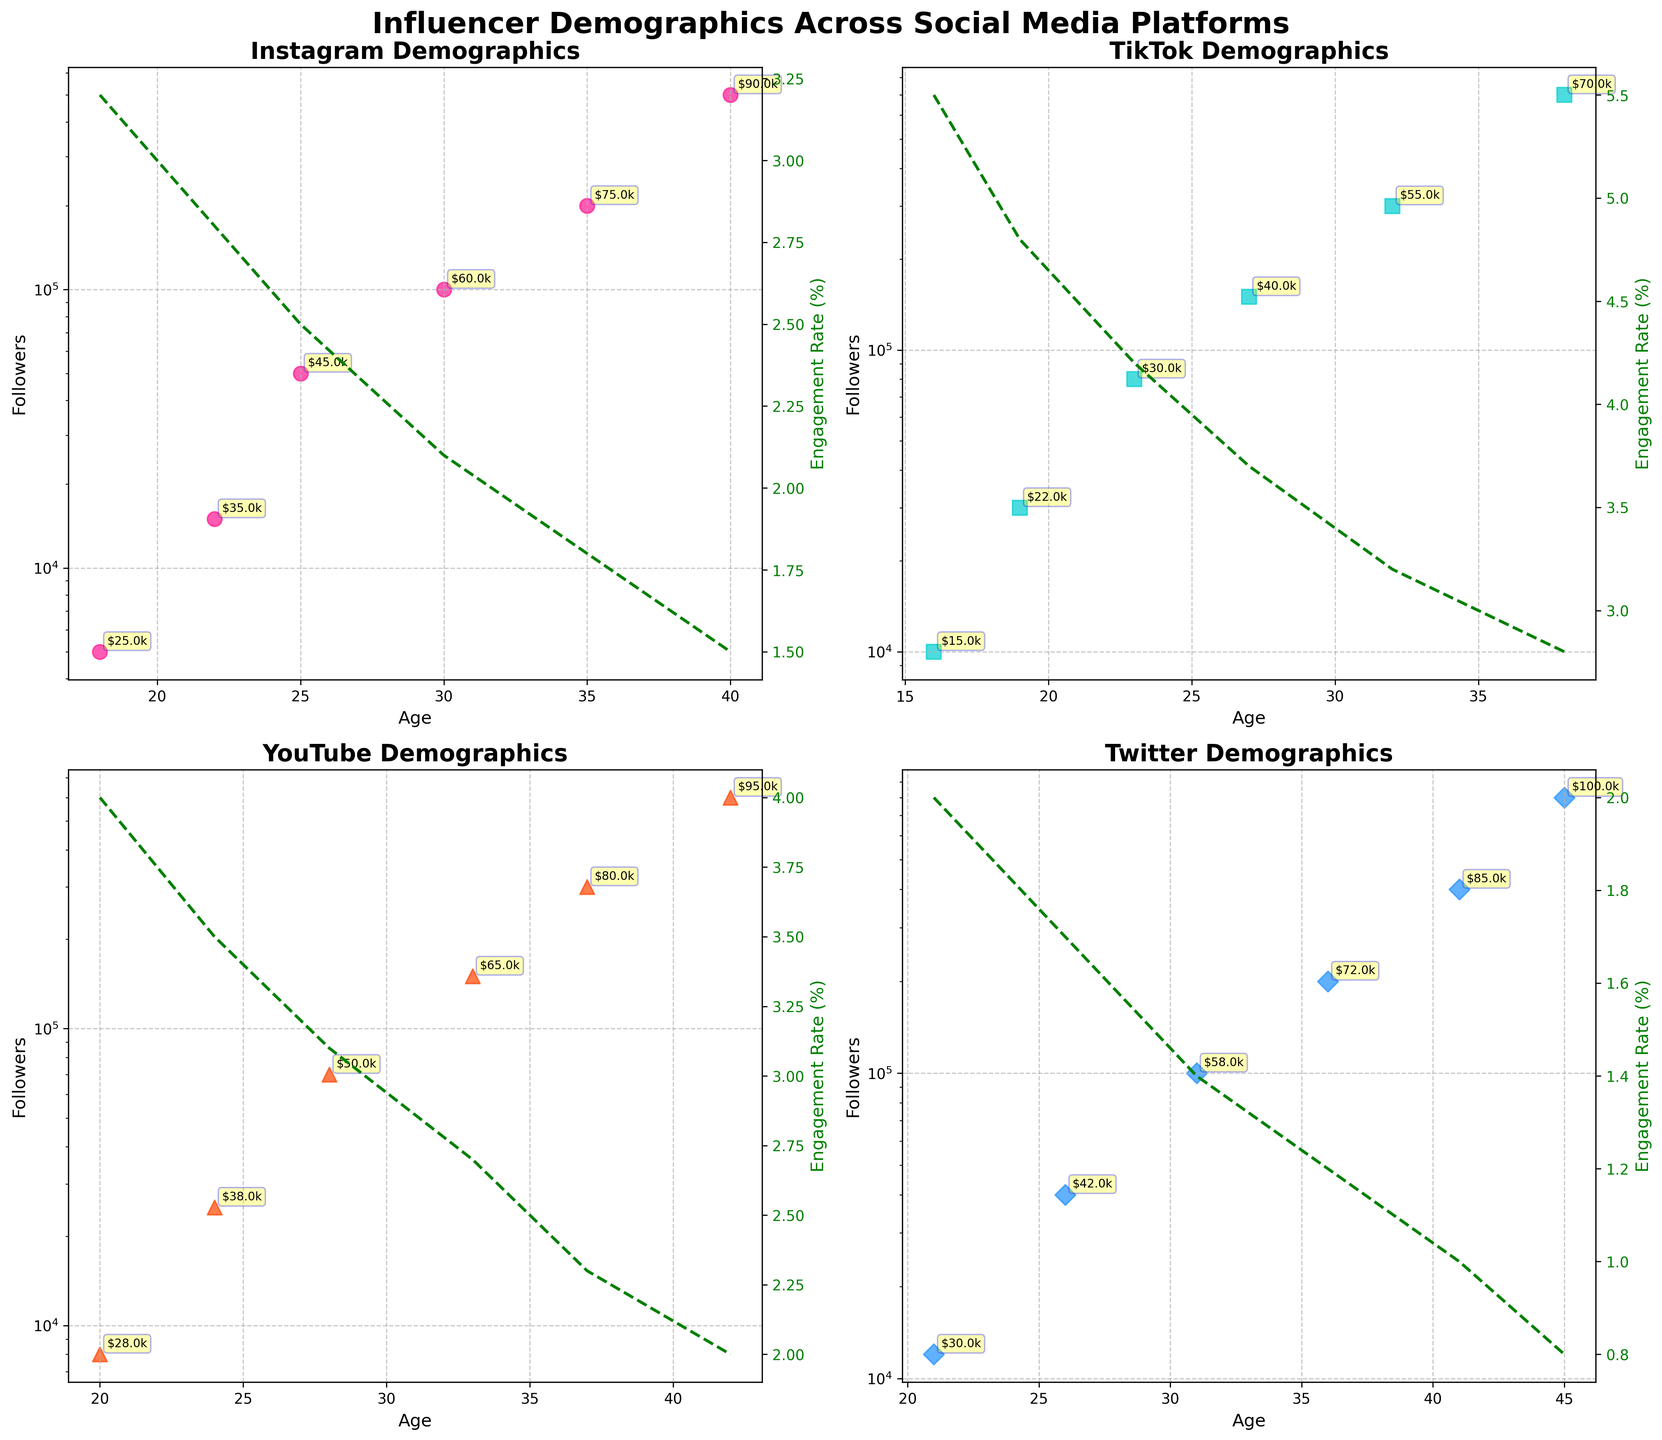Which platform has the highest engagement rate for the youngest age group? By examining the plots for engagement rates, the youngest age group corresponds to Instagram (age 18), TikTok (age 16), YouTube (age 20), and Twitter (age 21). TikTok shows the highest engagement rate at 5.5% for age 16.
Answer: TikTok Which platform shows the most significant drop in engagement rate from the age 30 to above? Observing the slopes of engagement rate lines from age 30 and below, Instagram's engagement rate significantly decreases while TikTok maintains a higher rate. Instagram drops from 2.1% at age 30 to 1.5% at age 40.
Answer: Instagram How does the number of followers for TikTok change with age compared to YouTube? Both platforms show an increase in followers with age; however, TikTok's increase is more exponential compared to YouTube’s more linear growth. For example, TikTok ranges from 10,000 followers at age 16 to 700,000 at age 38, whereas YouTube ranges from 8,000 followers at age 20 to 600,000 at age 42.
Answer: TikTok increases more exponentially Which platform's followers have the highest income at age 35 and above? The annotations for income levels at age 35 and above show that Twitter has $72,000 at age 36, $85,000 at age 41, and $100,000 at age 45, which are higher compared to other platforms.
Answer: Twitter What is the average engagement rate for YouTube followers across different age groups? The engagement rates for YouTube across ages 20, 24, 28, 33, 37, and 42 are 4.0%, 3.5%, 3.1%, 2.7%, 2.3%, and 2.0%. The sum is 17.6%, thus the average is 17.6/6 ≈ 2.93%.
Answer: 2.93% Which platform has the most followers at age 32 and what is their engagement rate? By looking at the annotations, at age 32, TikTok has 300,000 followers and an engagement rate of 3.2%.
Answer: TikTok, 3.2% Compare the engagement rates of YouTube and Twitter at age 24 and determine which is higher. At age 24, YouTube has an engagement rate of 3.5% while Twitter has an engagement rate of 1.7%. Therefore, the engagement rate for YouTube is higher.
Answer: YouTube How does the income level for Twitter followers at age 31 compare to that of Instagram followers at age 30? The income level for Twitter followers at age 31 is $58,000, while for Instagram followers at age 30, it is $60,000. Hence, Instagram followers have a higher income.
Answer: Instagram, $60,000 vs. $58,000 